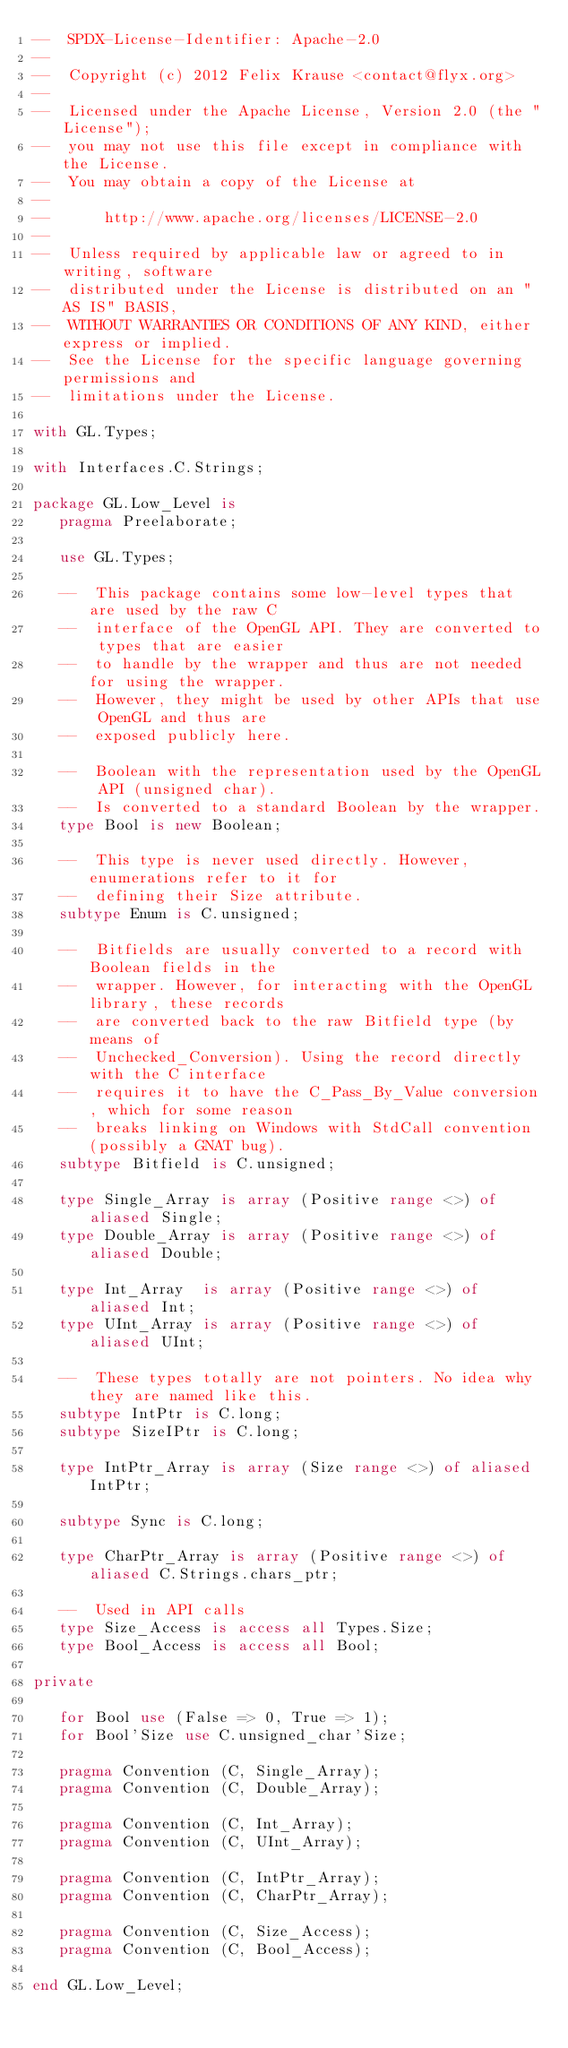<code> <loc_0><loc_0><loc_500><loc_500><_Ada_>--  SPDX-License-Identifier: Apache-2.0
--
--  Copyright (c) 2012 Felix Krause <contact@flyx.org>
--
--  Licensed under the Apache License, Version 2.0 (the "License");
--  you may not use this file except in compliance with the License.
--  You may obtain a copy of the License at
--
--      http://www.apache.org/licenses/LICENSE-2.0
--
--  Unless required by applicable law or agreed to in writing, software
--  distributed under the License is distributed on an "AS IS" BASIS,
--  WITHOUT WARRANTIES OR CONDITIONS OF ANY KIND, either express or implied.
--  See the License for the specific language governing permissions and
--  limitations under the License.

with GL.Types;

with Interfaces.C.Strings;

package GL.Low_Level is
   pragma Preelaborate;

   use GL.Types;

   --  This package contains some low-level types that are used by the raw C
   --  interface of the OpenGL API. They are converted to types that are easier
   --  to handle by the wrapper and thus are not needed for using the wrapper.
   --  However, they might be used by other APIs that use OpenGL and thus are
   --  exposed publicly here.

   --  Boolean with the representation used by the OpenGL API (unsigned char).
   --  Is converted to a standard Boolean by the wrapper.
   type Bool is new Boolean;

   --  This type is never used directly. However, enumerations refer to it for
   --  defining their Size attribute.
   subtype Enum is C.unsigned;

   --  Bitfields are usually converted to a record with Boolean fields in the
   --  wrapper. However, for interacting with the OpenGL library, these records
   --  are converted back to the raw Bitfield type (by means of
   --  Unchecked_Conversion). Using the record directly with the C interface
   --  requires it to have the C_Pass_By_Value conversion, which for some reason
   --  breaks linking on Windows with StdCall convention (possibly a GNAT bug).
   subtype Bitfield is C.unsigned;

   type Single_Array is array (Positive range <>) of aliased Single;
   type Double_Array is array (Positive range <>) of aliased Double;

   type Int_Array  is array (Positive range <>) of aliased Int;
   type UInt_Array is array (Positive range <>) of aliased UInt;

   --  These types totally are not pointers. No idea why they are named like this.
   subtype IntPtr is C.long;
   subtype SizeIPtr is C.long;

   type IntPtr_Array is array (Size range <>) of aliased IntPtr;

   subtype Sync is C.long;

   type CharPtr_Array is array (Positive range <>) of aliased C.Strings.chars_ptr;

   --  Used in API calls
   type Size_Access is access all Types.Size;
   type Bool_Access is access all Bool;

private

   for Bool use (False => 0, True => 1);
   for Bool'Size use C.unsigned_char'Size;

   pragma Convention (C, Single_Array);
   pragma Convention (C, Double_Array);

   pragma Convention (C, Int_Array);
   pragma Convention (C, UInt_Array);

   pragma Convention (C, IntPtr_Array);
   pragma Convention (C, CharPtr_Array);

   pragma Convention (C, Size_Access);
   pragma Convention (C, Bool_Access);

end GL.Low_Level;
</code> 